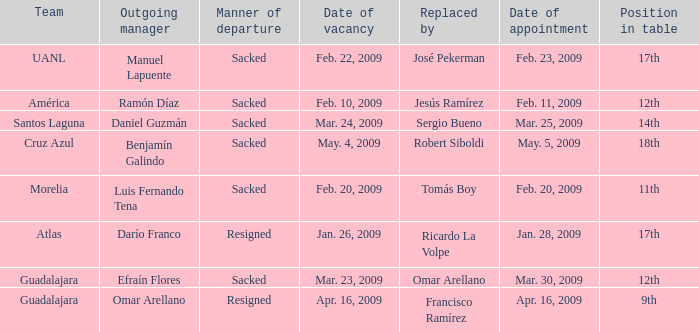What is Position in Table, when Team is "Morelia"? 11th. 